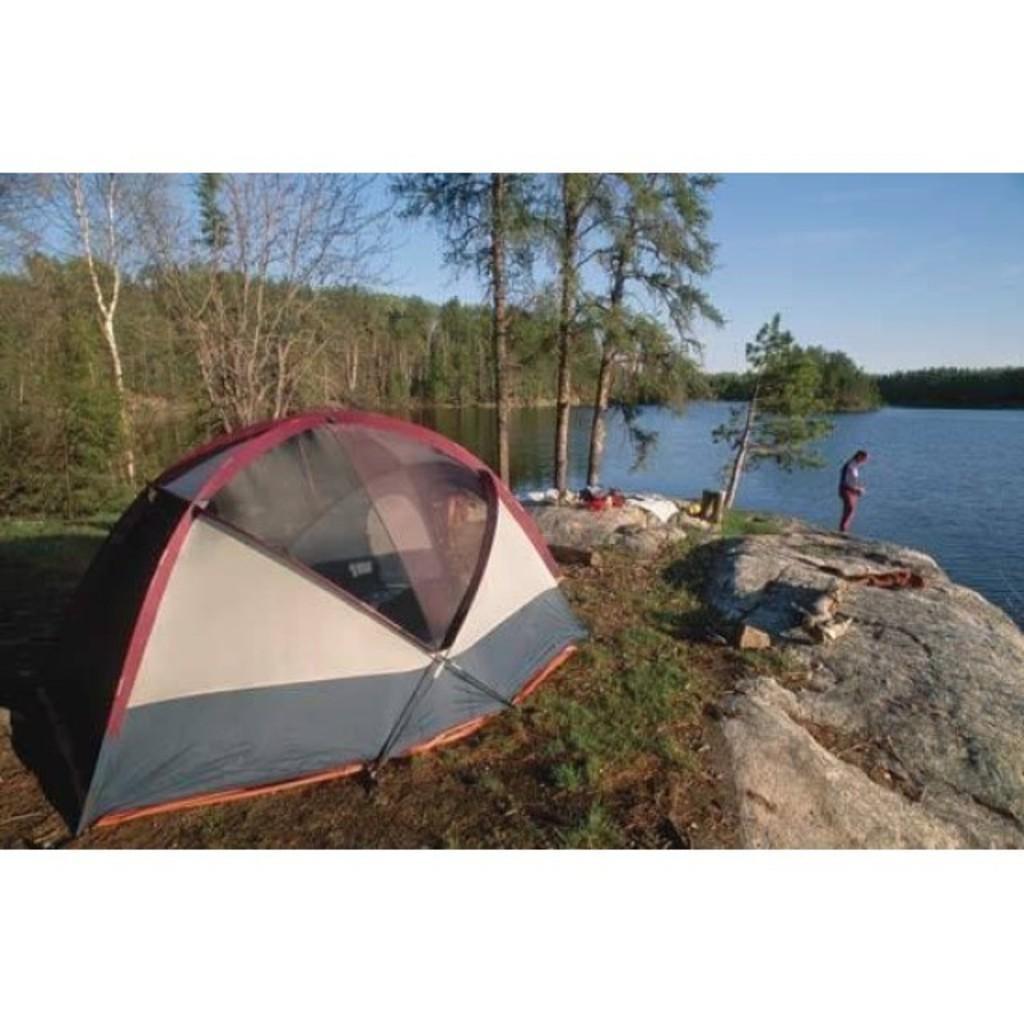Can you describe this image briefly? In this image we can see a tent, person standing on the rocks, trees, lake and sky with clouds. 